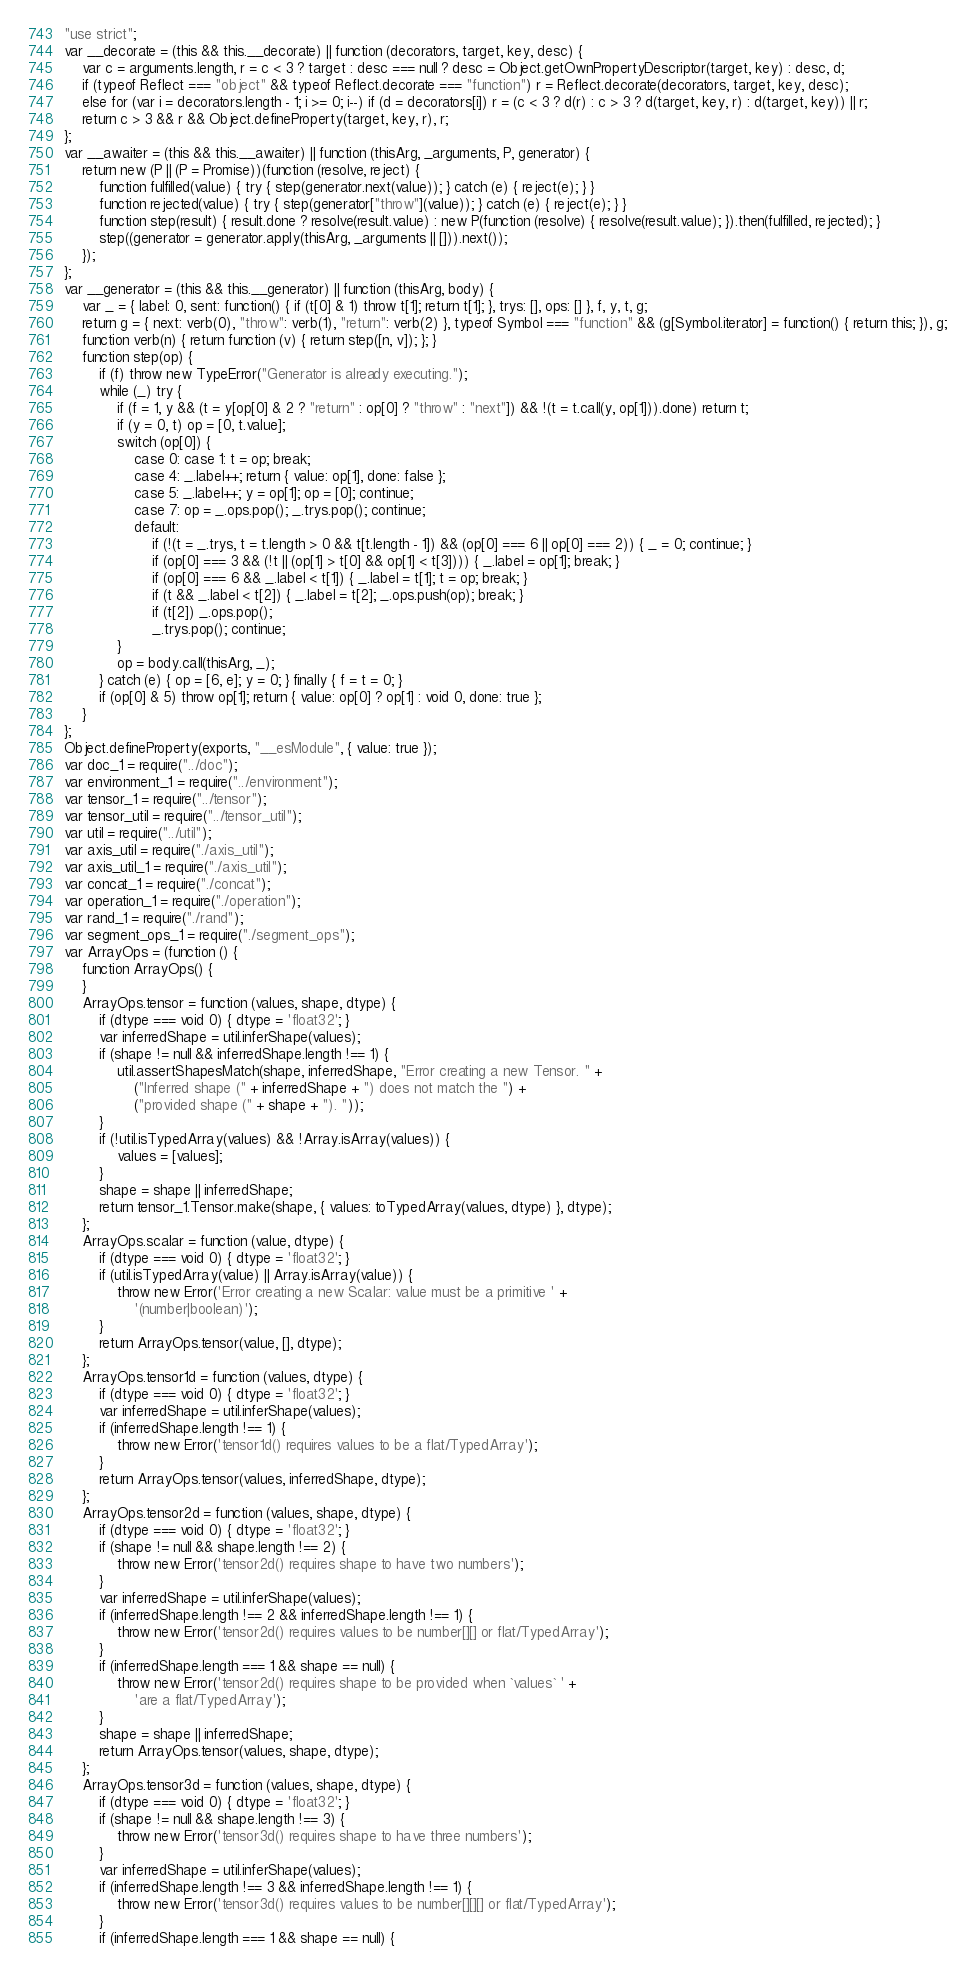Convert code to text. <code><loc_0><loc_0><loc_500><loc_500><_JavaScript_>"use strict";
var __decorate = (this && this.__decorate) || function (decorators, target, key, desc) {
    var c = arguments.length, r = c < 3 ? target : desc === null ? desc = Object.getOwnPropertyDescriptor(target, key) : desc, d;
    if (typeof Reflect === "object" && typeof Reflect.decorate === "function") r = Reflect.decorate(decorators, target, key, desc);
    else for (var i = decorators.length - 1; i >= 0; i--) if (d = decorators[i]) r = (c < 3 ? d(r) : c > 3 ? d(target, key, r) : d(target, key)) || r;
    return c > 3 && r && Object.defineProperty(target, key, r), r;
};
var __awaiter = (this && this.__awaiter) || function (thisArg, _arguments, P, generator) {
    return new (P || (P = Promise))(function (resolve, reject) {
        function fulfilled(value) { try { step(generator.next(value)); } catch (e) { reject(e); } }
        function rejected(value) { try { step(generator["throw"](value)); } catch (e) { reject(e); } }
        function step(result) { result.done ? resolve(result.value) : new P(function (resolve) { resolve(result.value); }).then(fulfilled, rejected); }
        step((generator = generator.apply(thisArg, _arguments || [])).next());
    });
};
var __generator = (this && this.__generator) || function (thisArg, body) {
    var _ = { label: 0, sent: function() { if (t[0] & 1) throw t[1]; return t[1]; }, trys: [], ops: [] }, f, y, t, g;
    return g = { next: verb(0), "throw": verb(1), "return": verb(2) }, typeof Symbol === "function" && (g[Symbol.iterator] = function() { return this; }), g;
    function verb(n) { return function (v) { return step([n, v]); }; }
    function step(op) {
        if (f) throw new TypeError("Generator is already executing.");
        while (_) try {
            if (f = 1, y && (t = y[op[0] & 2 ? "return" : op[0] ? "throw" : "next"]) && !(t = t.call(y, op[1])).done) return t;
            if (y = 0, t) op = [0, t.value];
            switch (op[0]) {
                case 0: case 1: t = op; break;
                case 4: _.label++; return { value: op[1], done: false };
                case 5: _.label++; y = op[1]; op = [0]; continue;
                case 7: op = _.ops.pop(); _.trys.pop(); continue;
                default:
                    if (!(t = _.trys, t = t.length > 0 && t[t.length - 1]) && (op[0] === 6 || op[0] === 2)) { _ = 0; continue; }
                    if (op[0] === 3 && (!t || (op[1] > t[0] && op[1] < t[3]))) { _.label = op[1]; break; }
                    if (op[0] === 6 && _.label < t[1]) { _.label = t[1]; t = op; break; }
                    if (t && _.label < t[2]) { _.label = t[2]; _.ops.push(op); break; }
                    if (t[2]) _.ops.pop();
                    _.trys.pop(); continue;
            }
            op = body.call(thisArg, _);
        } catch (e) { op = [6, e]; y = 0; } finally { f = t = 0; }
        if (op[0] & 5) throw op[1]; return { value: op[0] ? op[1] : void 0, done: true };
    }
};
Object.defineProperty(exports, "__esModule", { value: true });
var doc_1 = require("../doc");
var environment_1 = require("../environment");
var tensor_1 = require("../tensor");
var tensor_util = require("../tensor_util");
var util = require("../util");
var axis_util = require("./axis_util");
var axis_util_1 = require("./axis_util");
var concat_1 = require("./concat");
var operation_1 = require("./operation");
var rand_1 = require("./rand");
var segment_ops_1 = require("./segment_ops");
var ArrayOps = (function () {
    function ArrayOps() {
    }
    ArrayOps.tensor = function (values, shape, dtype) {
        if (dtype === void 0) { dtype = 'float32'; }
        var inferredShape = util.inferShape(values);
        if (shape != null && inferredShape.length !== 1) {
            util.assertShapesMatch(shape, inferredShape, "Error creating a new Tensor. " +
                ("Inferred shape (" + inferredShape + ") does not match the ") +
                ("provided shape (" + shape + "). "));
        }
        if (!util.isTypedArray(values) && !Array.isArray(values)) {
            values = [values];
        }
        shape = shape || inferredShape;
        return tensor_1.Tensor.make(shape, { values: toTypedArray(values, dtype) }, dtype);
    };
    ArrayOps.scalar = function (value, dtype) {
        if (dtype === void 0) { dtype = 'float32'; }
        if (util.isTypedArray(value) || Array.isArray(value)) {
            throw new Error('Error creating a new Scalar: value must be a primitive ' +
                '(number|boolean)');
        }
        return ArrayOps.tensor(value, [], dtype);
    };
    ArrayOps.tensor1d = function (values, dtype) {
        if (dtype === void 0) { dtype = 'float32'; }
        var inferredShape = util.inferShape(values);
        if (inferredShape.length !== 1) {
            throw new Error('tensor1d() requires values to be a flat/TypedArray');
        }
        return ArrayOps.tensor(values, inferredShape, dtype);
    };
    ArrayOps.tensor2d = function (values, shape, dtype) {
        if (dtype === void 0) { dtype = 'float32'; }
        if (shape != null && shape.length !== 2) {
            throw new Error('tensor2d() requires shape to have two numbers');
        }
        var inferredShape = util.inferShape(values);
        if (inferredShape.length !== 2 && inferredShape.length !== 1) {
            throw new Error('tensor2d() requires values to be number[][] or flat/TypedArray');
        }
        if (inferredShape.length === 1 && shape == null) {
            throw new Error('tensor2d() requires shape to be provided when `values` ' +
                'are a flat/TypedArray');
        }
        shape = shape || inferredShape;
        return ArrayOps.tensor(values, shape, dtype);
    };
    ArrayOps.tensor3d = function (values, shape, dtype) {
        if (dtype === void 0) { dtype = 'float32'; }
        if (shape != null && shape.length !== 3) {
            throw new Error('tensor3d() requires shape to have three numbers');
        }
        var inferredShape = util.inferShape(values);
        if (inferredShape.length !== 3 && inferredShape.length !== 1) {
            throw new Error('tensor3d() requires values to be number[][][] or flat/TypedArray');
        }
        if (inferredShape.length === 1 && shape == null) {</code> 